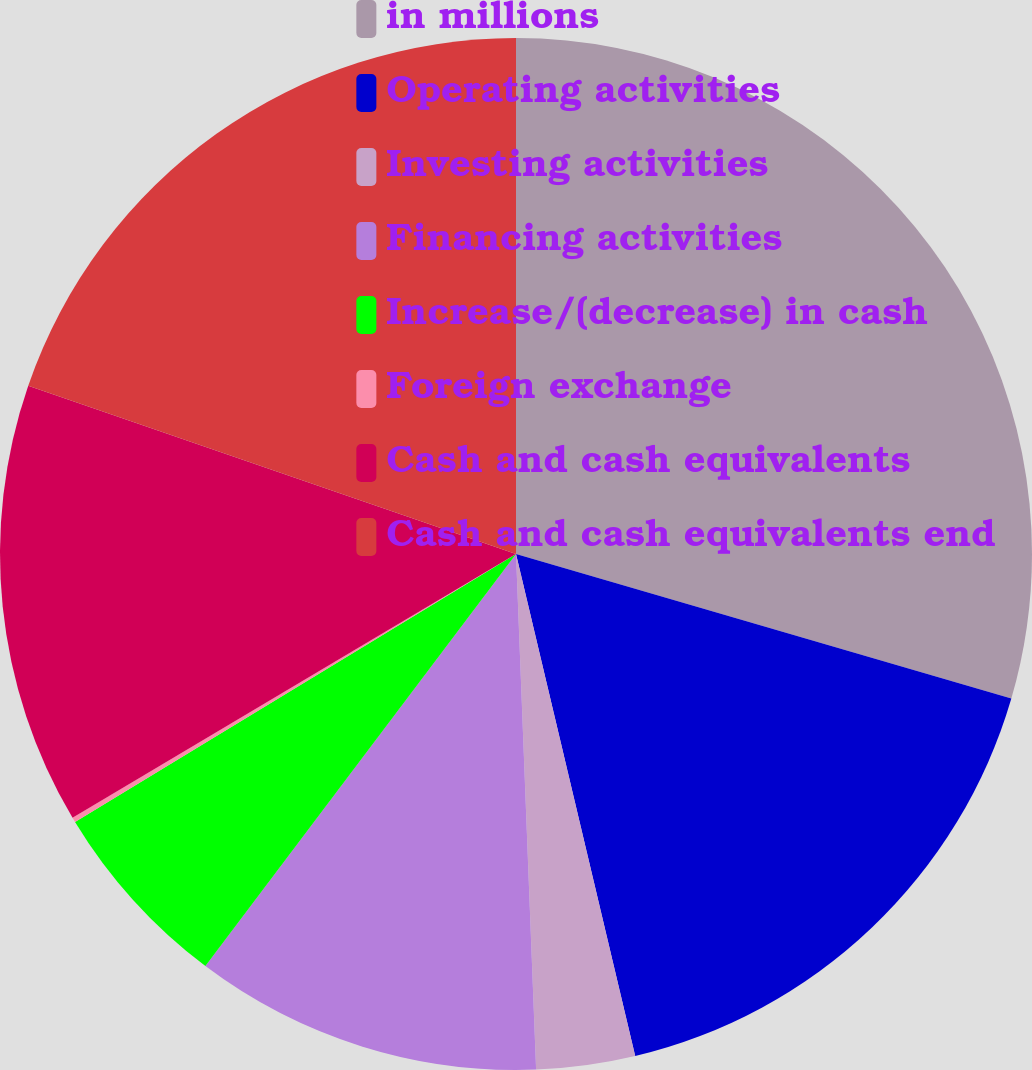Convert chart. <chart><loc_0><loc_0><loc_500><loc_500><pie_chart><fcel>in millions<fcel>Operating activities<fcel>Investing activities<fcel>Financing activities<fcel>Increase/(decrease) in cash<fcel>Foreign exchange<fcel>Cash and cash equivalents<fcel>Cash and cash equivalents end<nl><fcel>29.52%<fcel>16.77%<fcel>3.09%<fcel>10.9%<fcel>6.03%<fcel>0.15%<fcel>13.83%<fcel>19.71%<nl></chart> 